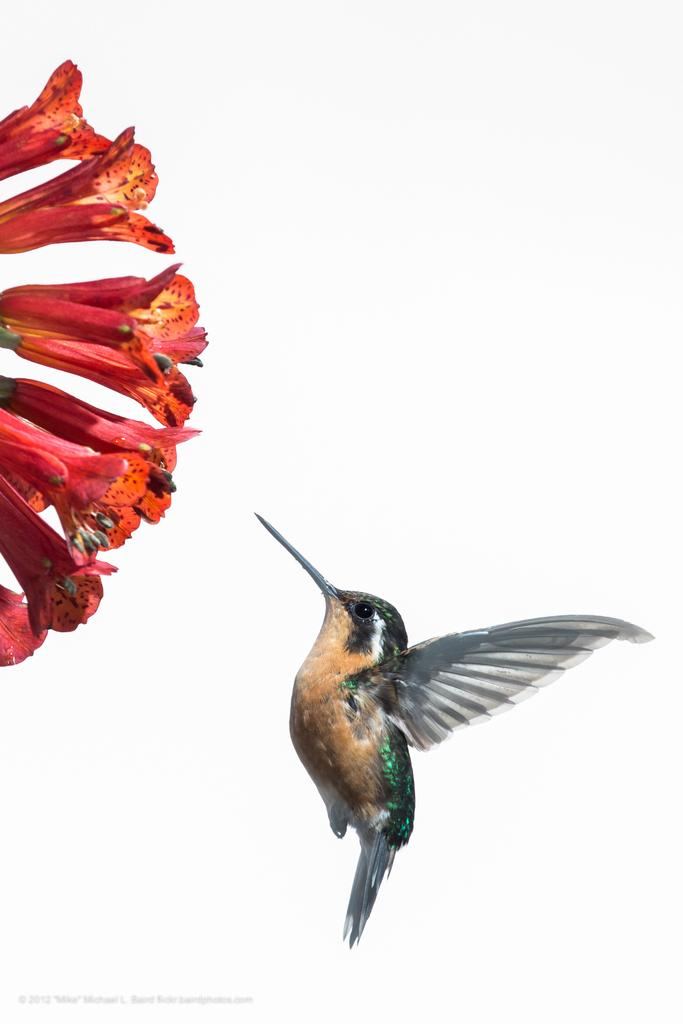What type of animal can be seen in the image? There is a bird in the image. What else is present at the bottom of the image? There is text visible at the bottom of the image. What kind of vegetation is on the left side of the image? There are flowers on the left side of the image. What color is the background of the image? The background of the image is white. Where is the bird's nest located in the image? There is no nest visible in the image; only the bird is present. What type of cushion can be seen supporting the bird in the image? There is no cushion present in the image; the bird is not resting on any support. 